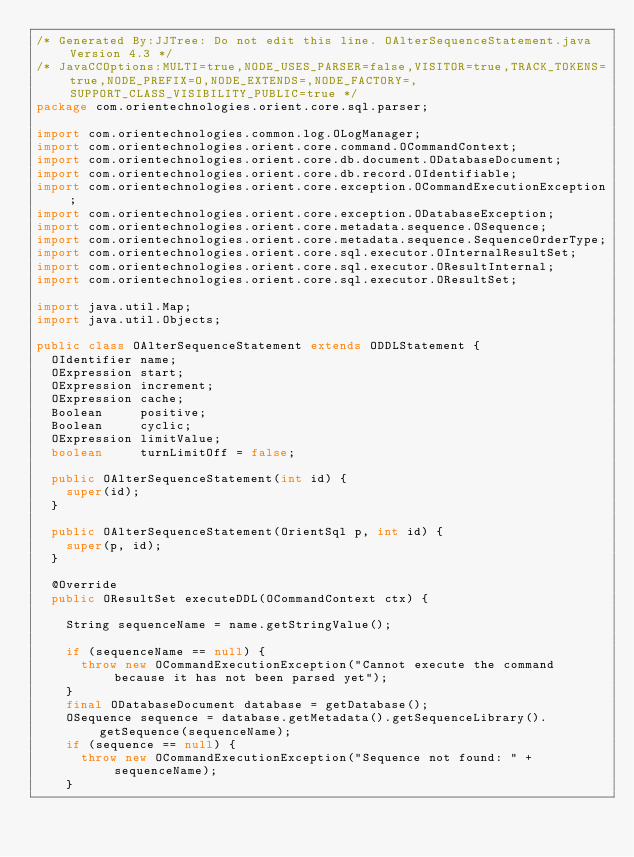Convert code to text. <code><loc_0><loc_0><loc_500><loc_500><_Java_>/* Generated By:JJTree: Do not edit this line. OAlterSequenceStatement.java Version 4.3 */
/* JavaCCOptions:MULTI=true,NODE_USES_PARSER=false,VISITOR=true,TRACK_TOKENS=true,NODE_PREFIX=O,NODE_EXTENDS=,NODE_FACTORY=,SUPPORT_CLASS_VISIBILITY_PUBLIC=true */
package com.orientechnologies.orient.core.sql.parser;

import com.orientechnologies.common.log.OLogManager;
import com.orientechnologies.orient.core.command.OCommandContext;
import com.orientechnologies.orient.core.db.document.ODatabaseDocument;
import com.orientechnologies.orient.core.db.record.OIdentifiable;
import com.orientechnologies.orient.core.exception.OCommandExecutionException;
import com.orientechnologies.orient.core.exception.ODatabaseException;
import com.orientechnologies.orient.core.metadata.sequence.OSequence;
import com.orientechnologies.orient.core.metadata.sequence.SequenceOrderType;
import com.orientechnologies.orient.core.sql.executor.OInternalResultSet;
import com.orientechnologies.orient.core.sql.executor.OResultInternal;
import com.orientechnologies.orient.core.sql.executor.OResultSet;

import java.util.Map;
import java.util.Objects;

public class OAlterSequenceStatement extends ODDLStatement {
  OIdentifier name;
  OExpression start;
  OExpression increment;
  OExpression cache;
  Boolean     positive;
  Boolean     cyclic;
  OExpression limitValue;
  boolean     turnLimitOff = false;

  public OAlterSequenceStatement(int id) {
    super(id);
  }

  public OAlterSequenceStatement(OrientSql p, int id) {
    super(p, id);
  }

  @Override
  public OResultSet executeDDL(OCommandContext ctx) {

    String sequenceName = name.getStringValue();

    if (sequenceName == null) {
      throw new OCommandExecutionException("Cannot execute the command because it has not been parsed yet");
    }
    final ODatabaseDocument database = getDatabase();
    OSequence sequence = database.getMetadata().getSequenceLibrary().getSequence(sequenceName);
    if (sequence == null) {
      throw new OCommandExecutionException("Sequence not found: " + sequenceName);
    }
</code> 